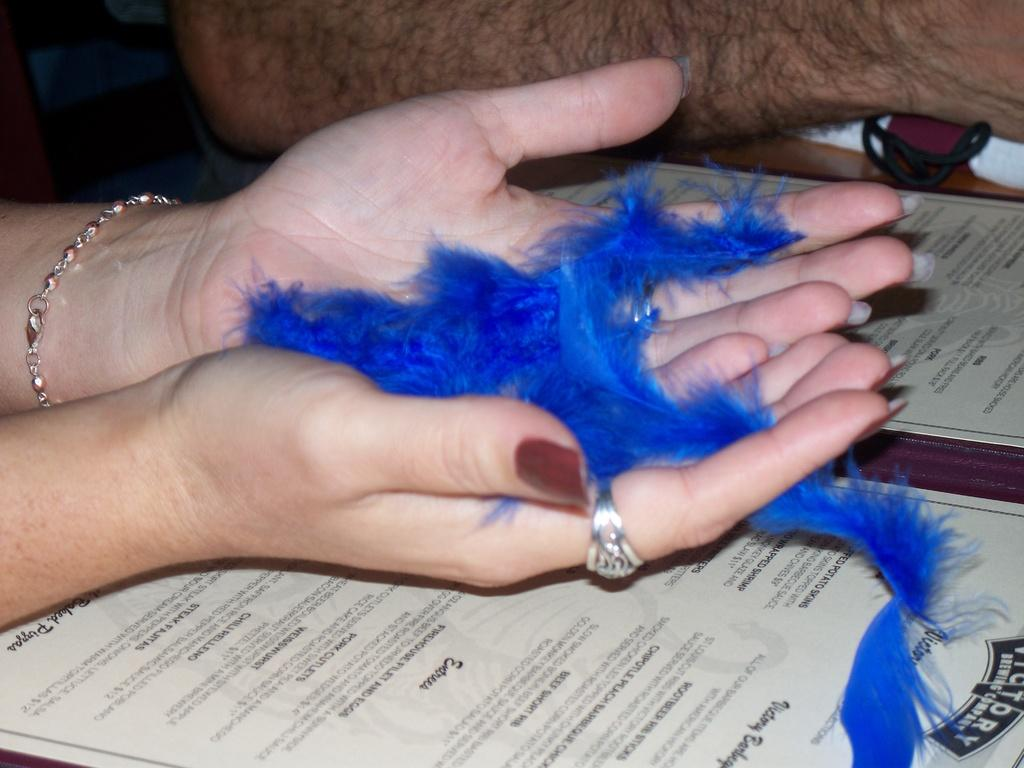What can be seen in the image involving two people? The hands of two persons are in the image. What are the hands holding? The hands appear to be holding certificates. Is there any additional element in the hands? Yes, there is a ribbon visible in the hands. What type of stove can be seen in the image? There is no stove present in the image. Is there a church visible in the image? No, there is no church visible in the image. 